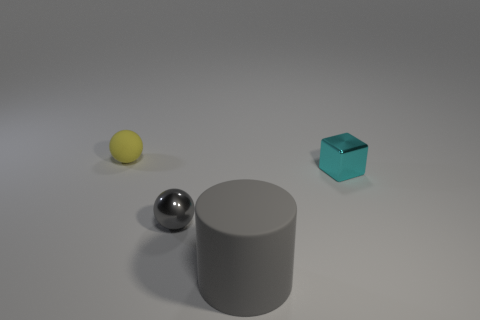Add 3 small red rubber objects. How many objects exist? 7 Subtract all blocks. How many objects are left? 3 Add 1 yellow spheres. How many yellow spheres are left? 2 Add 3 gray balls. How many gray balls exist? 4 Subtract 0 purple cylinders. How many objects are left? 4 Subtract all large brown matte spheres. Subtract all tiny cyan objects. How many objects are left? 3 